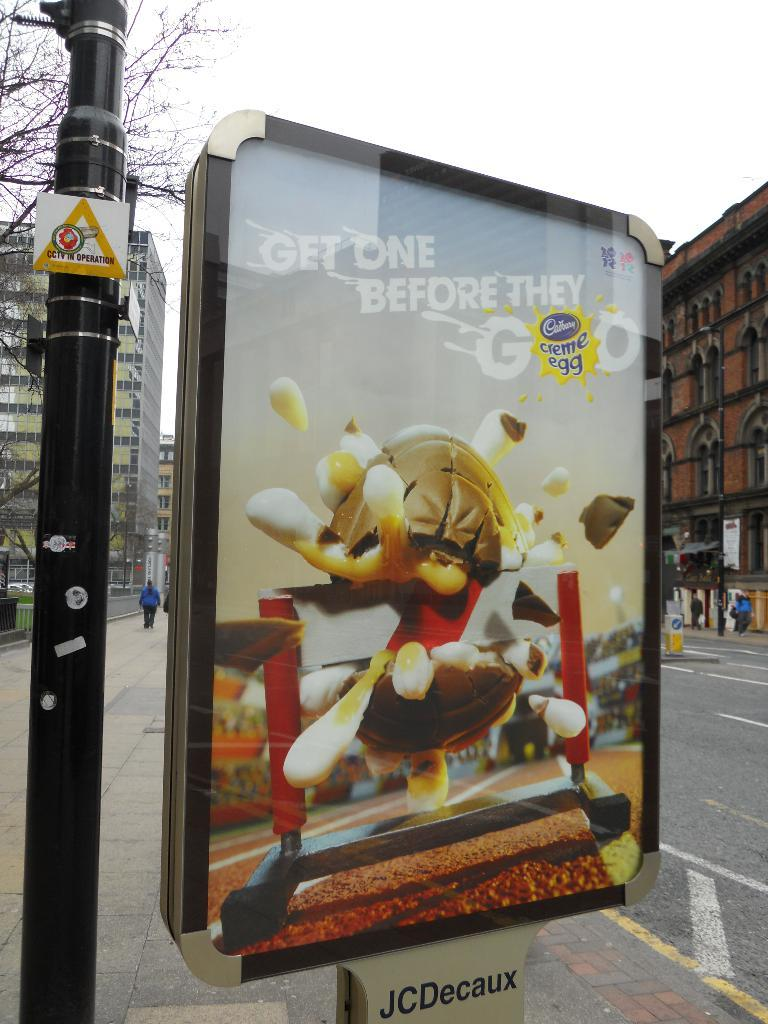<image>
Create a compact narrative representing the image presented. A poster sized advertisement for Cadbury creme eggs, encased in thick plastic, is standing on the sidewalk, next to the road, saying get them before they are gone. 